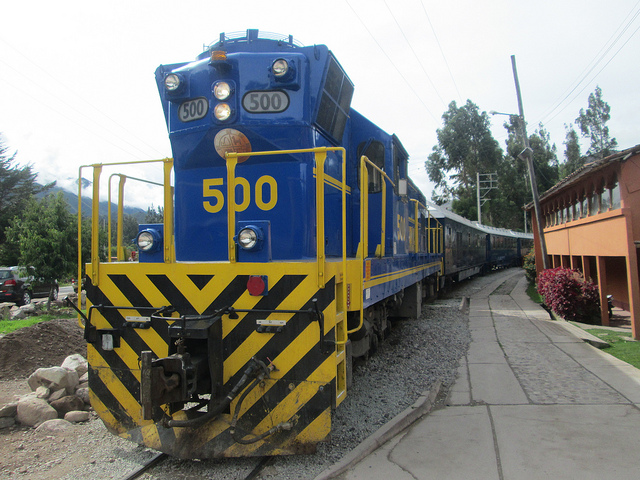Read all the text in this image. 500 500 500 